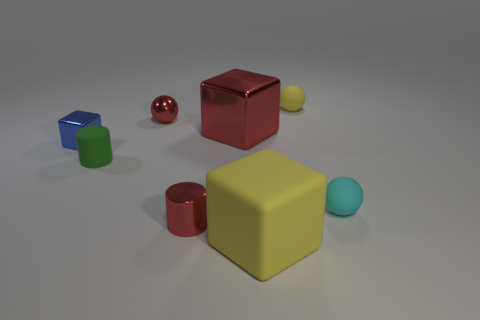Add 1 small yellow things. How many objects exist? 9 Subtract all cylinders. How many objects are left? 6 Subtract all big rubber objects. Subtract all red metal cylinders. How many objects are left? 6 Add 5 blue objects. How many blue objects are left? 6 Add 4 tiny green rubber cylinders. How many tiny green rubber cylinders exist? 5 Subtract 1 blue blocks. How many objects are left? 7 